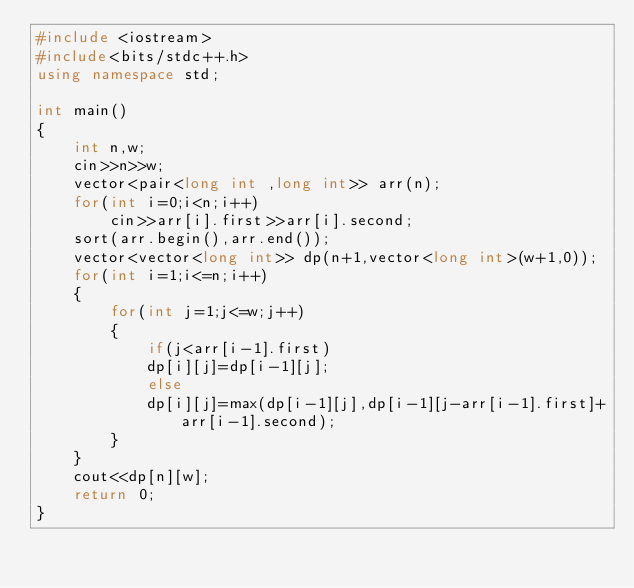Convert code to text. <code><loc_0><loc_0><loc_500><loc_500><_C++_>#include <iostream>
#include<bits/stdc++.h>
using namespace std;

int main()
{
    int n,w;
    cin>>n>>w;
    vector<pair<long int ,long int>> arr(n);
    for(int i=0;i<n;i++)
        cin>>arr[i].first>>arr[i].second;
    sort(arr.begin(),arr.end());
    vector<vector<long int>> dp(n+1,vector<long int>(w+1,0));
    for(int i=1;i<=n;i++)
    {
        for(int j=1;j<=w;j++)
        {
            if(j<arr[i-1].first)
            dp[i][j]=dp[i-1][j];
            else
            dp[i][j]=max(dp[i-1][j],dp[i-1][j-arr[i-1].first]+arr[i-1].second);
        }
    }
    cout<<dp[n][w];
    return 0;
}
</code> 